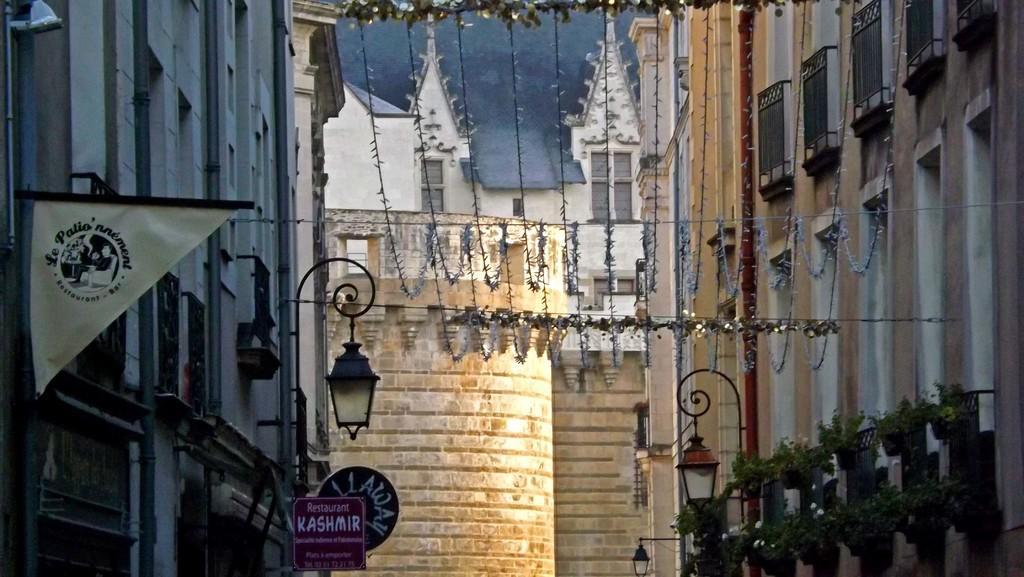Can you describe this image briefly? There are many buildings and below the buildings there are few restaurants. There are two street lights on the either side of the buildings and between the buildings there is some decorative wires are hanged with some lights. 